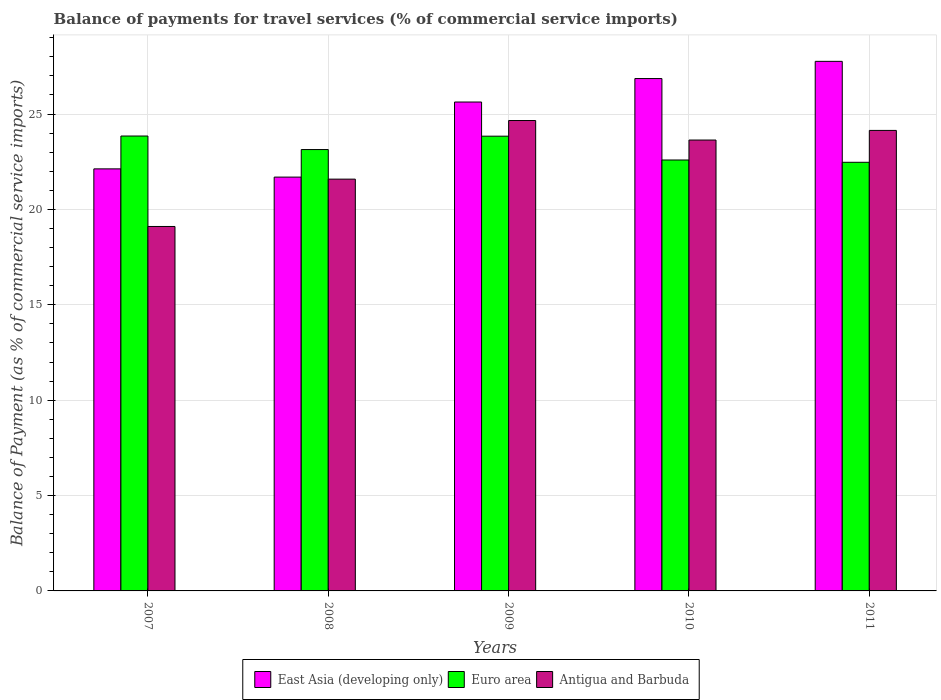How many groups of bars are there?
Provide a succinct answer. 5. Are the number of bars per tick equal to the number of legend labels?
Your answer should be compact. Yes. Are the number of bars on each tick of the X-axis equal?
Your answer should be compact. Yes. What is the balance of payments for travel services in East Asia (developing only) in 2010?
Your answer should be very brief. 26.86. Across all years, what is the maximum balance of payments for travel services in Euro area?
Make the answer very short. 23.85. Across all years, what is the minimum balance of payments for travel services in Antigua and Barbuda?
Make the answer very short. 19.11. In which year was the balance of payments for travel services in East Asia (developing only) maximum?
Give a very brief answer. 2011. In which year was the balance of payments for travel services in East Asia (developing only) minimum?
Keep it short and to the point. 2008. What is the total balance of payments for travel services in East Asia (developing only) in the graph?
Provide a short and direct response. 124.07. What is the difference between the balance of payments for travel services in East Asia (developing only) in 2009 and that in 2010?
Your answer should be very brief. -1.23. What is the difference between the balance of payments for travel services in Antigua and Barbuda in 2008 and the balance of payments for travel services in Euro area in 2011?
Provide a short and direct response. -0.88. What is the average balance of payments for travel services in East Asia (developing only) per year?
Your answer should be compact. 24.81. In the year 2010, what is the difference between the balance of payments for travel services in Antigua and Barbuda and balance of payments for travel services in East Asia (developing only)?
Your answer should be very brief. -3.22. In how many years, is the balance of payments for travel services in Euro area greater than 12 %?
Provide a succinct answer. 5. What is the ratio of the balance of payments for travel services in East Asia (developing only) in 2007 to that in 2010?
Offer a very short reply. 0.82. Is the balance of payments for travel services in Antigua and Barbuda in 2009 less than that in 2010?
Ensure brevity in your answer.  No. Is the difference between the balance of payments for travel services in Antigua and Barbuda in 2008 and 2009 greater than the difference between the balance of payments for travel services in East Asia (developing only) in 2008 and 2009?
Ensure brevity in your answer.  Yes. What is the difference between the highest and the second highest balance of payments for travel services in Antigua and Barbuda?
Give a very brief answer. 0.52. What is the difference between the highest and the lowest balance of payments for travel services in Euro area?
Make the answer very short. 1.38. In how many years, is the balance of payments for travel services in East Asia (developing only) greater than the average balance of payments for travel services in East Asia (developing only) taken over all years?
Your answer should be compact. 3. Is the sum of the balance of payments for travel services in East Asia (developing only) in 2009 and 2011 greater than the maximum balance of payments for travel services in Antigua and Barbuda across all years?
Your answer should be very brief. Yes. What does the 1st bar from the left in 2007 represents?
Your response must be concise. East Asia (developing only). What does the 1st bar from the right in 2007 represents?
Provide a short and direct response. Antigua and Barbuda. Is it the case that in every year, the sum of the balance of payments for travel services in Antigua and Barbuda and balance of payments for travel services in Euro area is greater than the balance of payments for travel services in East Asia (developing only)?
Your response must be concise. Yes. How many bars are there?
Your answer should be compact. 15. Are all the bars in the graph horizontal?
Your response must be concise. No. What is the difference between two consecutive major ticks on the Y-axis?
Keep it short and to the point. 5. Does the graph contain any zero values?
Offer a very short reply. No. Where does the legend appear in the graph?
Give a very brief answer. Bottom center. How are the legend labels stacked?
Make the answer very short. Horizontal. What is the title of the graph?
Keep it short and to the point. Balance of payments for travel services (% of commercial service imports). What is the label or title of the Y-axis?
Your answer should be compact. Balance of Payment (as % of commercial service imports). What is the Balance of Payment (as % of commercial service imports) in East Asia (developing only) in 2007?
Provide a succinct answer. 22.13. What is the Balance of Payment (as % of commercial service imports) in Euro area in 2007?
Your response must be concise. 23.85. What is the Balance of Payment (as % of commercial service imports) in Antigua and Barbuda in 2007?
Your response must be concise. 19.11. What is the Balance of Payment (as % of commercial service imports) of East Asia (developing only) in 2008?
Your response must be concise. 21.69. What is the Balance of Payment (as % of commercial service imports) of Euro area in 2008?
Provide a short and direct response. 23.14. What is the Balance of Payment (as % of commercial service imports) of Antigua and Barbuda in 2008?
Make the answer very short. 21.59. What is the Balance of Payment (as % of commercial service imports) in East Asia (developing only) in 2009?
Make the answer very short. 25.63. What is the Balance of Payment (as % of commercial service imports) in Euro area in 2009?
Your answer should be compact. 23.84. What is the Balance of Payment (as % of commercial service imports) in Antigua and Barbuda in 2009?
Ensure brevity in your answer.  24.66. What is the Balance of Payment (as % of commercial service imports) in East Asia (developing only) in 2010?
Provide a short and direct response. 26.86. What is the Balance of Payment (as % of commercial service imports) in Euro area in 2010?
Give a very brief answer. 22.59. What is the Balance of Payment (as % of commercial service imports) in Antigua and Barbuda in 2010?
Your response must be concise. 23.64. What is the Balance of Payment (as % of commercial service imports) in East Asia (developing only) in 2011?
Provide a succinct answer. 27.76. What is the Balance of Payment (as % of commercial service imports) in Euro area in 2011?
Your response must be concise. 22.47. What is the Balance of Payment (as % of commercial service imports) in Antigua and Barbuda in 2011?
Your answer should be very brief. 24.14. Across all years, what is the maximum Balance of Payment (as % of commercial service imports) of East Asia (developing only)?
Your answer should be very brief. 27.76. Across all years, what is the maximum Balance of Payment (as % of commercial service imports) of Euro area?
Offer a terse response. 23.85. Across all years, what is the maximum Balance of Payment (as % of commercial service imports) in Antigua and Barbuda?
Provide a short and direct response. 24.66. Across all years, what is the minimum Balance of Payment (as % of commercial service imports) in East Asia (developing only)?
Your answer should be very brief. 21.69. Across all years, what is the minimum Balance of Payment (as % of commercial service imports) of Euro area?
Make the answer very short. 22.47. Across all years, what is the minimum Balance of Payment (as % of commercial service imports) of Antigua and Barbuda?
Your answer should be compact. 19.11. What is the total Balance of Payment (as % of commercial service imports) of East Asia (developing only) in the graph?
Provide a short and direct response. 124.07. What is the total Balance of Payment (as % of commercial service imports) of Euro area in the graph?
Your response must be concise. 115.89. What is the total Balance of Payment (as % of commercial service imports) in Antigua and Barbuda in the graph?
Your response must be concise. 113.13. What is the difference between the Balance of Payment (as % of commercial service imports) of East Asia (developing only) in 2007 and that in 2008?
Your response must be concise. 0.43. What is the difference between the Balance of Payment (as % of commercial service imports) of Euro area in 2007 and that in 2008?
Provide a succinct answer. 0.71. What is the difference between the Balance of Payment (as % of commercial service imports) of Antigua and Barbuda in 2007 and that in 2008?
Provide a short and direct response. -2.48. What is the difference between the Balance of Payment (as % of commercial service imports) in East Asia (developing only) in 2007 and that in 2009?
Make the answer very short. -3.5. What is the difference between the Balance of Payment (as % of commercial service imports) in Euro area in 2007 and that in 2009?
Keep it short and to the point. 0.01. What is the difference between the Balance of Payment (as % of commercial service imports) of Antigua and Barbuda in 2007 and that in 2009?
Your answer should be very brief. -5.55. What is the difference between the Balance of Payment (as % of commercial service imports) of East Asia (developing only) in 2007 and that in 2010?
Make the answer very short. -4.73. What is the difference between the Balance of Payment (as % of commercial service imports) in Euro area in 2007 and that in 2010?
Provide a short and direct response. 1.26. What is the difference between the Balance of Payment (as % of commercial service imports) in Antigua and Barbuda in 2007 and that in 2010?
Your answer should be compact. -4.53. What is the difference between the Balance of Payment (as % of commercial service imports) in East Asia (developing only) in 2007 and that in 2011?
Your answer should be compact. -5.64. What is the difference between the Balance of Payment (as % of commercial service imports) of Euro area in 2007 and that in 2011?
Ensure brevity in your answer.  1.38. What is the difference between the Balance of Payment (as % of commercial service imports) of Antigua and Barbuda in 2007 and that in 2011?
Ensure brevity in your answer.  -5.04. What is the difference between the Balance of Payment (as % of commercial service imports) in East Asia (developing only) in 2008 and that in 2009?
Provide a succinct answer. -3.94. What is the difference between the Balance of Payment (as % of commercial service imports) of Euro area in 2008 and that in 2009?
Ensure brevity in your answer.  -0.7. What is the difference between the Balance of Payment (as % of commercial service imports) of Antigua and Barbuda in 2008 and that in 2009?
Your answer should be compact. -3.07. What is the difference between the Balance of Payment (as % of commercial service imports) in East Asia (developing only) in 2008 and that in 2010?
Offer a very short reply. -5.17. What is the difference between the Balance of Payment (as % of commercial service imports) in Euro area in 2008 and that in 2010?
Ensure brevity in your answer.  0.55. What is the difference between the Balance of Payment (as % of commercial service imports) of Antigua and Barbuda in 2008 and that in 2010?
Your answer should be compact. -2.05. What is the difference between the Balance of Payment (as % of commercial service imports) in East Asia (developing only) in 2008 and that in 2011?
Your answer should be very brief. -6.07. What is the difference between the Balance of Payment (as % of commercial service imports) in Euro area in 2008 and that in 2011?
Offer a terse response. 0.67. What is the difference between the Balance of Payment (as % of commercial service imports) in Antigua and Barbuda in 2008 and that in 2011?
Your answer should be very brief. -2.55. What is the difference between the Balance of Payment (as % of commercial service imports) of East Asia (developing only) in 2009 and that in 2010?
Offer a very short reply. -1.23. What is the difference between the Balance of Payment (as % of commercial service imports) of Euro area in 2009 and that in 2010?
Ensure brevity in your answer.  1.25. What is the difference between the Balance of Payment (as % of commercial service imports) in Antigua and Barbuda in 2009 and that in 2010?
Your answer should be compact. 1.02. What is the difference between the Balance of Payment (as % of commercial service imports) in East Asia (developing only) in 2009 and that in 2011?
Keep it short and to the point. -2.13. What is the difference between the Balance of Payment (as % of commercial service imports) of Euro area in 2009 and that in 2011?
Provide a short and direct response. 1.37. What is the difference between the Balance of Payment (as % of commercial service imports) in Antigua and Barbuda in 2009 and that in 2011?
Give a very brief answer. 0.52. What is the difference between the Balance of Payment (as % of commercial service imports) of East Asia (developing only) in 2010 and that in 2011?
Your response must be concise. -0.9. What is the difference between the Balance of Payment (as % of commercial service imports) of Euro area in 2010 and that in 2011?
Ensure brevity in your answer.  0.12. What is the difference between the Balance of Payment (as % of commercial service imports) in Antigua and Barbuda in 2010 and that in 2011?
Offer a very short reply. -0.5. What is the difference between the Balance of Payment (as % of commercial service imports) in East Asia (developing only) in 2007 and the Balance of Payment (as % of commercial service imports) in Euro area in 2008?
Give a very brief answer. -1.01. What is the difference between the Balance of Payment (as % of commercial service imports) in East Asia (developing only) in 2007 and the Balance of Payment (as % of commercial service imports) in Antigua and Barbuda in 2008?
Provide a short and direct response. 0.54. What is the difference between the Balance of Payment (as % of commercial service imports) of Euro area in 2007 and the Balance of Payment (as % of commercial service imports) of Antigua and Barbuda in 2008?
Make the answer very short. 2.26. What is the difference between the Balance of Payment (as % of commercial service imports) in East Asia (developing only) in 2007 and the Balance of Payment (as % of commercial service imports) in Euro area in 2009?
Provide a short and direct response. -1.71. What is the difference between the Balance of Payment (as % of commercial service imports) in East Asia (developing only) in 2007 and the Balance of Payment (as % of commercial service imports) in Antigua and Barbuda in 2009?
Ensure brevity in your answer.  -2.54. What is the difference between the Balance of Payment (as % of commercial service imports) in Euro area in 2007 and the Balance of Payment (as % of commercial service imports) in Antigua and Barbuda in 2009?
Ensure brevity in your answer.  -0.81. What is the difference between the Balance of Payment (as % of commercial service imports) of East Asia (developing only) in 2007 and the Balance of Payment (as % of commercial service imports) of Euro area in 2010?
Provide a short and direct response. -0.47. What is the difference between the Balance of Payment (as % of commercial service imports) in East Asia (developing only) in 2007 and the Balance of Payment (as % of commercial service imports) in Antigua and Barbuda in 2010?
Your answer should be compact. -1.51. What is the difference between the Balance of Payment (as % of commercial service imports) in Euro area in 2007 and the Balance of Payment (as % of commercial service imports) in Antigua and Barbuda in 2010?
Your answer should be very brief. 0.21. What is the difference between the Balance of Payment (as % of commercial service imports) of East Asia (developing only) in 2007 and the Balance of Payment (as % of commercial service imports) of Euro area in 2011?
Keep it short and to the point. -0.35. What is the difference between the Balance of Payment (as % of commercial service imports) in East Asia (developing only) in 2007 and the Balance of Payment (as % of commercial service imports) in Antigua and Barbuda in 2011?
Provide a succinct answer. -2.02. What is the difference between the Balance of Payment (as % of commercial service imports) of Euro area in 2007 and the Balance of Payment (as % of commercial service imports) of Antigua and Barbuda in 2011?
Your response must be concise. -0.29. What is the difference between the Balance of Payment (as % of commercial service imports) of East Asia (developing only) in 2008 and the Balance of Payment (as % of commercial service imports) of Euro area in 2009?
Make the answer very short. -2.15. What is the difference between the Balance of Payment (as % of commercial service imports) of East Asia (developing only) in 2008 and the Balance of Payment (as % of commercial service imports) of Antigua and Barbuda in 2009?
Make the answer very short. -2.97. What is the difference between the Balance of Payment (as % of commercial service imports) in Euro area in 2008 and the Balance of Payment (as % of commercial service imports) in Antigua and Barbuda in 2009?
Provide a succinct answer. -1.52. What is the difference between the Balance of Payment (as % of commercial service imports) of East Asia (developing only) in 2008 and the Balance of Payment (as % of commercial service imports) of Euro area in 2010?
Your answer should be compact. -0.9. What is the difference between the Balance of Payment (as % of commercial service imports) in East Asia (developing only) in 2008 and the Balance of Payment (as % of commercial service imports) in Antigua and Barbuda in 2010?
Offer a very short reply. -1.94. What is the difference between the Balance of Payment (as % of commercial service imports) of Euro area in 2008 and the Balance of Payment (as % of commercial service imports) of Antigua and Barbuda in 2010?
Offer a very short reply. -0.5. What is the difference between the Balance of Payment (as % of commercial service imports) in East Asia (developing only) in 2008 and the Balance of Payment (as % of commercial service imports) in Euro area in 2011?
Keep it short and to the point. -0.78. What is the difference between the Balance of Payment (as % of commercial service imports) of East Asia (developing only) in 2008 and the Balance of Payment (as % of commercial service imports) of Antigua and Barbuda in 2011?
Provide a short and direct response. -2.45. What is the difference between the Balance of Payment (as % of commercial service imports) in Euro area in 2008 and the Balance of Payment (as % of commercial service imports) in Antigua and Barbuda in 2011?
Make the answer very short. -1. What is the difference between the Balance of Payment (as % of commercial service imports) in East Asia (developing only) in 2009 and the Balance of Payment (as % of commercial service imports) in Euro area in 2010?
Ensure brevity in your answer.  3.04. What is the difference between the Balance of Payment (as % of commercial service imports) of East Asia (developing only) in 2009 and the Balance of Payment (as % of commercial service imports) of Antigua and Barbuda in 2010?
Make the answer very short. 1.99. What is the difference between the Balance of Payment (as % of commercial service imports) of Euro area in 2009 and the Balance of Payment (as % of commercial service imports) of Antigua and Barbuda in 2010?
Ensure brevity in your answer.  0.2. What is the difference between the Balance of Payment (as % of commercial service imports) in East Asia (developing only) in 2009 and the Balance of Payment (as % of commercial service imports) in Euro area in 2011?
Give a very brief answer. 3.16. What is the difference between the Balance of Payment (as % of commercial service imports) in East Asia (developing only) in 2009 and the Balance of Payment (as % of commercial service imports) in Antigua and Barbuda in 2011?
Offer a terse response. 1.49. What is the difference between the Balance of Payment (as % of commercial service imports) in Euro area in 2009 and the Balance of Payment (as % of commercial service imports) in Antigua and Barbuda in 2011?
Ensure brevity in your answer.  -0.3. What is the difference between the Balance of Payment (as % of commercial service imports) of East Asia (developing only) in 2010 and the Balance of Payment (as % of commercial service imports) of Euro area in 2011?
Keep it short and to the point. 4.39. What is the difference between the Balance of Payment (as % of commercial service imports) in East Asia (developing only) in 2010 and the Balance of Payment (as % of commercial service imports) in Antigua and Barbuda in 2011?
Give a very brief answer. 2.72. What is the difference between the Balance of Payment (as % of commercial service imports) of Euro area in 2010 and the Balance of Payment (as % of commercial service imports) of Antigua and Barbuda in 2011?
Your response must be concise. -1.55. What is the average Balance of Payment (as % of commercial service imports) in East Asia (developing only) per year?
Give a very brief answer. 24.81. What is the average Balance of Payment (as % of commercial service imports) in Euro area per year?
Ensure brevity in your answer.  23.18. What is the average Balance of Payment (as % of commercial service imports) in Antigua and Barbuda per year?
Provide a short and direct response. 22.63. In the year 2007, what is the difference between the Balance of Payment (as % of commercial service imports) of East Asia (developing only) and Balance of Payment (as % of commercial service imports) of Euro area?
Provide a succinct answer. -1.72. In the year 2007, what is the difference between the Balance of Payment (as % of commercial service imports) in East Asia (developing only) and Balance of Payment (as % of commercial service imports) in Antigua and Barbuda?
Provide a short and direct response. 3.02. In the year 2007, what is the difference between the Balance of Payment (as % of commercial service imports) of Euro area and Balance of Payment (as % of commercial service imports) of Antigua and Barbuda?
Give a very brief answer. 4.74. In the year 2008, what is the difference between the Balance of Payment (as % of commercial service imports) in East Asia (developing only) and Balance of Payment (as % of commercial service imports) in Euro area?
Provide a succinct answer. -1.44. In the year 2008, what is the difference between the Balance of Payment (as % of commercial service imports) of East Asia (developing only) and Balance of Payment (as % of commercial service imports) of Antigua and Barbuda?
Offer a terse response. 0.11. In the year 2008, what is the difference between the Balance of Payment (as % of commercial service imports) of Euro area and Balance of Payment (as % of commercial service imports) of Antigua and Barbuda?
Your response must be concise. 1.55. In the year 2009, what is the difference between the Balance of Payment (as % of commercial service imports) of East Asia (developing only) and Balance of Payment (as % of commercial service imports) of Euro area?
Make the answer very short. 1.79. In the year 2009, what is the difference between the Balance of Payment (as % of commercial service imports) of East Asia (developing only) and Balance of Payment (as % of commercial service imports) of Antigua and Barbuda?
Your response must be concise. 0.97. In the year 2009, what is the difference between the Balance of Payment (as % of commercial service imports) in Euro area and Balance of Payment (as % of commercial service imports) in Antigua and Barbuda?
Your answer should be compact. -0.82. In the year 2010, what is the difference between the Balance of Payment (as % of commercial service imports) of East Asia (developing only) and Balance of Payment (as % of commercial service imports) of Euro area?
Keep it short and to the point. 4.27. In the year 2010, what is the difference between the Balance of Payment (as % of commercial service imports) in East Asia (developing only) and Balance of Payment (as % of commercial service imports) in Antigua and Barbuda?
Provide a short and direct response. 3.22. In the year 2010, what is the difference between the Balance of Payment (as % of commercial service imports) of Euro area and Balance of Payment (as % of commercial service imports) of Antigua and Barbuda?
Ensure brevity in your answer.  -1.05. In the year 2011, what is the difference between the Balance of Payment (as % of commercial service imports) in East Asia (developing only) and Balance of Payment (as % of commercial service imports) in Euro area?
Make the answer very short. 5.29. In the year 2011, what is the difference between the Balance of Payment (as % of commercial service imports) of East Asia (developing only) and Balance of Payment (as % of commercial service imports) of Antigua and Barbuda?
Give a very brief answer. 3.62. In the year 2011, what is the difference between the Balance of Payment (as % of commercial service imports) in Euro area and Balance of Payment (as % of commercial service imports) in Antigua and Barbuda?
Provide a short and direct response. -1.67. What is the ratio of the Balance of Payment (as % of commercial service imports) in East Asia (developing only) in 2007 to that in 2008?
Offer a terse response. 1.02. What is the ratio of the Balance of Payment (as % of commercial service imports) in Euro area in 2007 to that in 2008?
Your response must be concise. 1.03. What is the ratio of the Balance of Payment (as % of commercial service imports) of Antigua and Barbuda in 2007 to that in 2008?
Your response must be concise. 0.89. What is the ratio of the Balance of Payment (as % of commercial service imports) of East Asia (developing only) in 2007 to that in 2009?
Ensure brevity in your answer.  0.86. What is the ratio of the Balance of Payment (as % of commercial service imports) of Antigua and Barbuda in 2007 to that in 2009?
Make the answer very short. 0.77. What is the ratio of the Balance of Payment (as % of commercial service imports) of East Asia (developing only) in 2007 to that in 2010?
Your answer should be compact. 0.82. What is the ratio of the Balance of Payment (as % of commercial service imports) in Euro area in 2007 to that in 2010?
Ensure brevity in your answer.  1.06. What is the ratio of the Balance of Payment (as % of commercial service imports) of Antigua and Barbuda in 2007 to that in 2010?
Give a very brief answer. 0.81. What is the ratio of the Balance of Payment (as % of commercial service imports) of East Asia (developing only) in 2007 to that in 2011?
Offer a terse response. 0.8. What is the ratio of the Balance of Payment (as % of commercial service imports) of Euro area in 2007 to that in 2011?
Provide a short and direct response. 1.06. What is the ratio of the Balance of Payment (as % of commercial service imports) in Antigua and Barbuda in 2007 to that in 2011?
Keep it short and to the point. 0.79. What is the ratio of the Balance of Payment (as % of commercial service imports) in East Asia (developing only) in 2008 to that in 2009?
Offer a very short reply. 0.85. What is the ratio of the Balance of Payment (as % of commercial service imports) of Euro area in 2008 to that in 2009?
Provide a short and direct response. 0.97. What is the ratio of the Balance of Payment (as % of commercial service imports) in Antigua and Barbuda in 2008 to that in 2009?
Your answer should be compact. 0.88. What is the ratio of the Balance of Payment (as % of commercial service imports) of East Asia (developing only) in 2008 to that in 2010?
Provide a succinct answer. 0.81. What is the ratio of the Balance of Payment (as % of commercial service imports) in Euro area in 2008 to that in 2010?
Your answer should be very brief. 1.02. What is the ratio of the Balance of Payment (as % of commercial service imports) in Antigua and Barbuda in 2008 to that in 2010?
Make the answer very short. 0.91. What is the ratio of the Balance of Payment (as % of commercial service imports) in East Asia (developing only) in 2008 to that in 2011?
Offer a terse response. 0.78. What is the ratio of the Balance of Payment (as % of commercial service imports) of Euro area in 2008 to that in 2011?
Your answer should be very brief. 1.03. What is the ratio of the Balance of Payment (as % of commercial service imports) in Antigua and Barbuda in 2008 to that in 2011?
Your response must be concise. 0.89. What is the ratio of the Balance of Payment (as % of commercial service imports) in East Asia (developing only) in 2009 to that in 2010?
Provide a succinct answer. 0.95. What is the ratio of the Balance of Payment (as % of commercial service imports) in Euro area in 2009 to that in 2010?
Offer a terse response. 1.06. What is the ratio of the Balance of Payment (as % of commercial service imports) in Antigua and Barbuda in 2009 to that in 2010?
Your answer should be compact. 1.04. What is the ratio of the Balance of Payment (as % of commercial service imports) of East Asia (developing only) in 2009 to that in 2011?
Offer a terse response. 0.92. What is the ratio of the Balance of Payment (as % of commercial service imports) in Euro area in 2009 to that in 2011?
Offer a terse response. 1.06. What is the ratio of the Balance of Payment (as % of commercial service imports) of Antigua and Barbuda in 2009 to that in 2011?
Make the answer very short. 1.02. What is the ratio of the Balance of Payment (as % of commercial service imports) in East Asia (developing only) in 2010 to that in 2011?
Provide a short and direct response. 0.97. What is the ratio of the Balance of Payment (as % of commercial service imports) of Antigua and Barbuda in 2010 to that in 2011?
Offer a very short reply. 0.98. What is the difference between the highest and the second highest Balance of Payment (as % of commercial service imports) of East Asia (developing only)?
Offer a terse response. 0.9. What is the difference between the highest and the second highest Balance of Payment (as % of commercial service imports) in Euro area?
Offer a very short reply. 0.01. What is the difference between the highest and the second highest Balance of Payment (as % of commercial service imports) in Antigua and Barbuda?
Provide a short and direct response. 0.52. What is the difference between the highest and the lowest Balance of Payment (as % of commercial service imports) of East Asia (developing only)?
Provide a short and direct response. 6.07. What is the difference between the highest and the lowest Balance of Payment (as % of commercial service imports) of Euro area?
Your answer should be very brief. 1.38. What is the difference between the highest and the lowest Balance of Payment (as % of commercial service imports) of Antigua and Barbuda?
Your answer should be very brief. 5.55. 